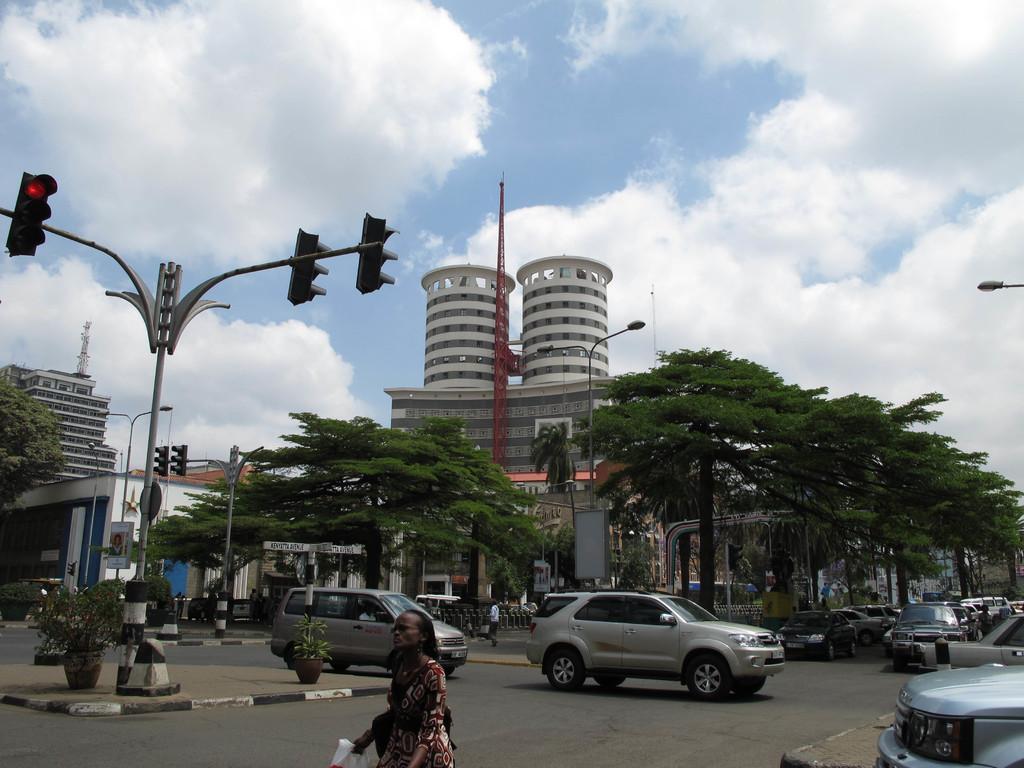Can you describe this image briefly? In this picture there are people and we can see vehicles on the road, plants with pots and trees. We can see traffic signals, boards and lights on poles and buildings. In the background of the image we can see the sky. 